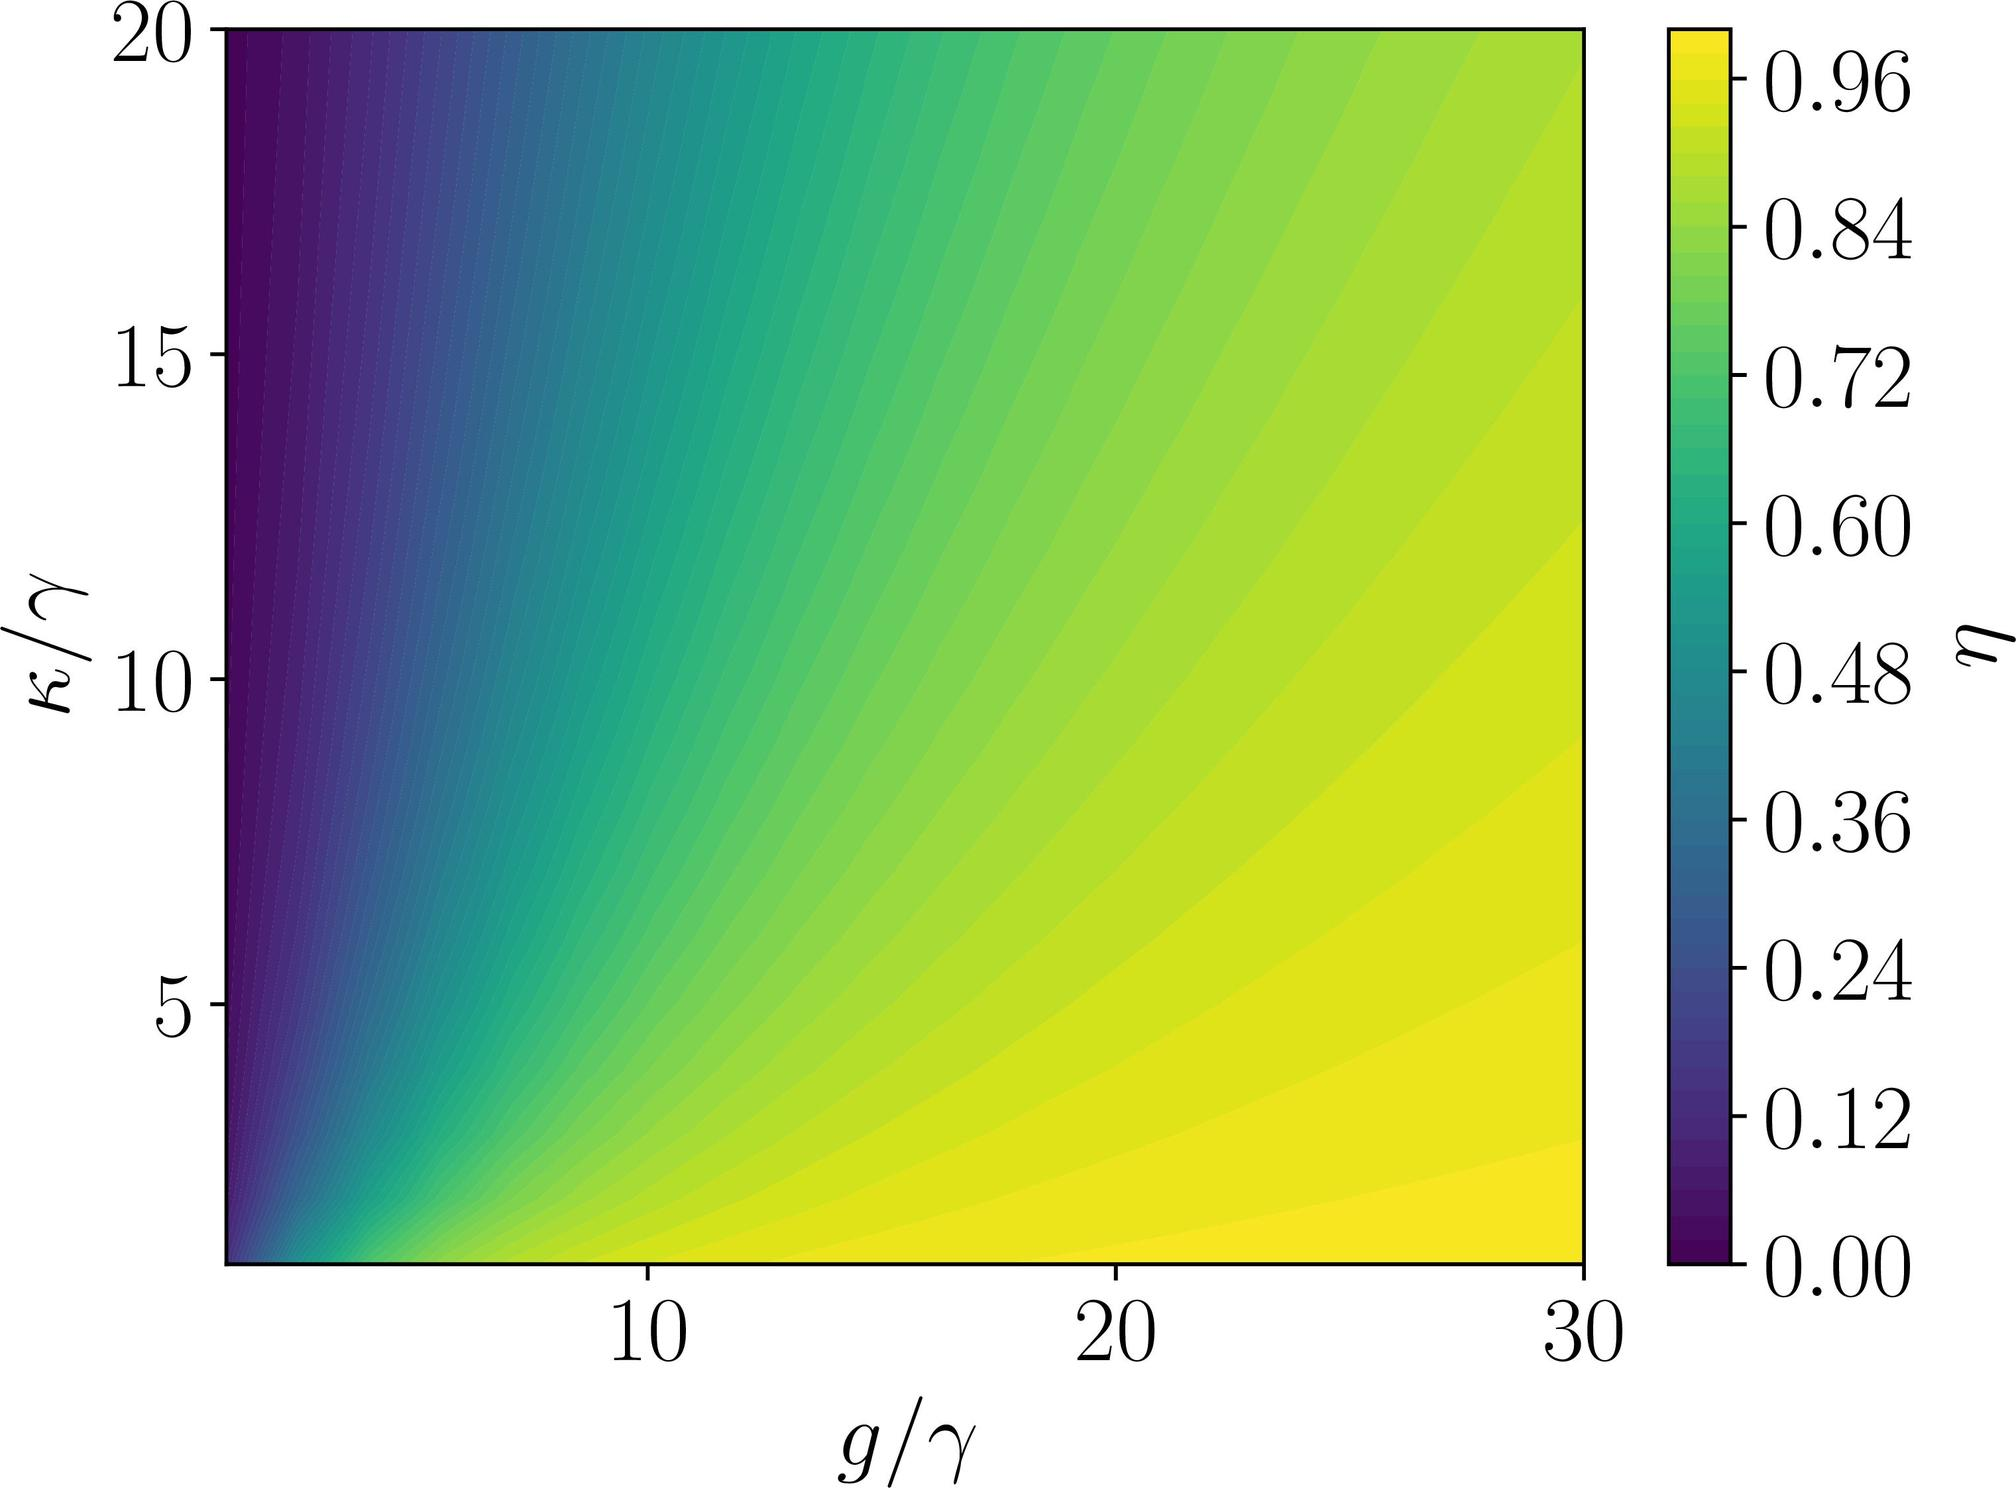How might this graph be useful in a practical application? Graphs like this one are particularly useful in engineering and scientific research to understand how a system's behavior or performance metric (in this case, \( \eta \)) varies with respect to different parameters (\( g/\gamma \) and \( \kappa/\gamma \)). By analyzing the contour lines, researchers can identify optimal operating conditions, explore sensitivity to parameter changes, or predict system behavior under different scenarios without comprehensive testing. This graph could be part of a design process, control system analysis, or optimization problem. 